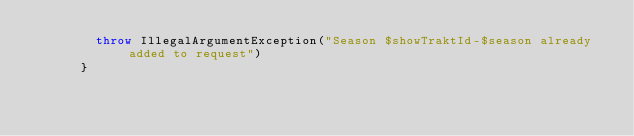<code> <loc_0><loc_0><loc_500><loc_500><_Kotlin_>        throw IllegalArgumentException("Season $showTraktId-$season already added to request")
      }</code> 